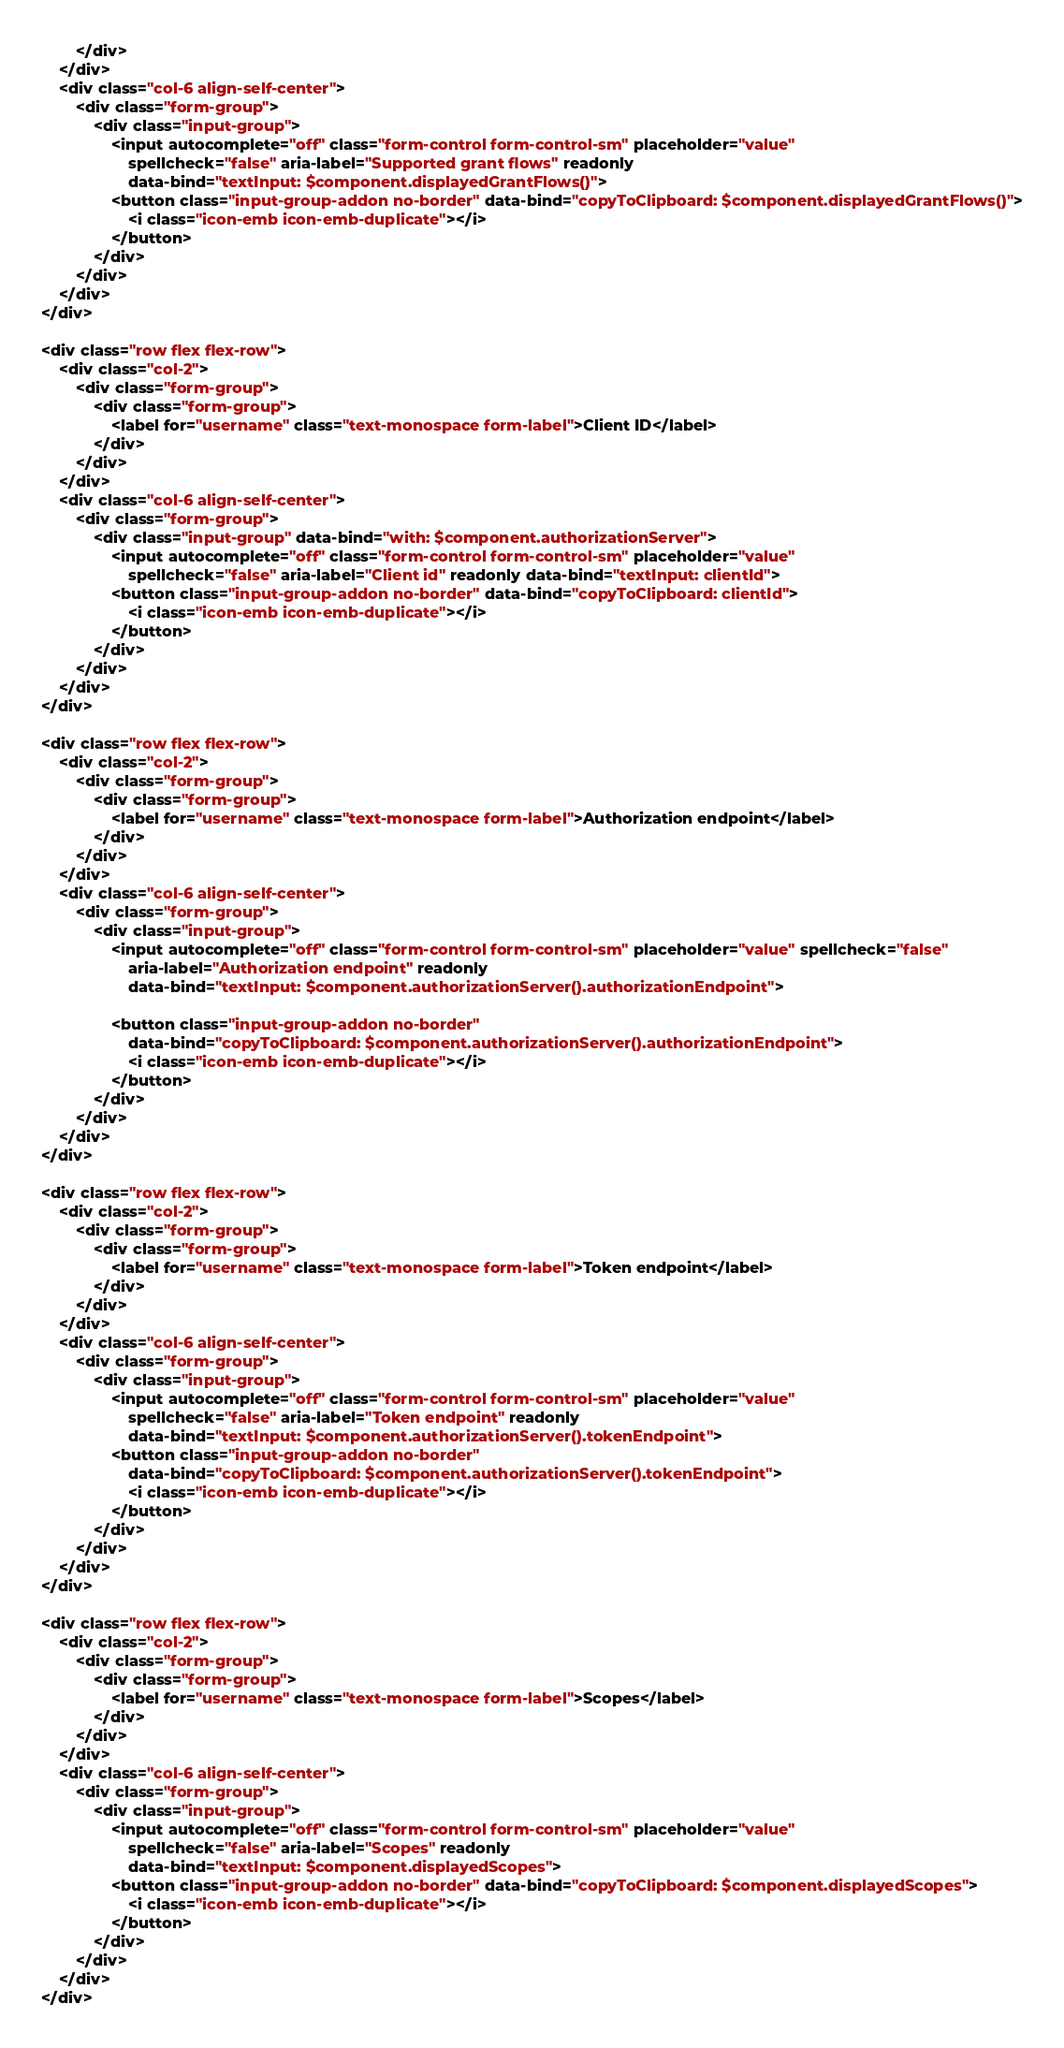<code> <loc_0><loc_0><loc_500><loc_500><_HTML_>        </div>
    </div>
    <div class="col-6 align-self-center">
        <div class="form-group">
            <div class="input-group">
                <input autocomplete="off" class="form-control form-control-sm" placeholder="value"
                    spellcheck="false" aria-label="Supported grant flows" readonly
                    data-bind="textInput: $component.displayedGrantFlows()">
                <button class="input-group-addon no-border" data-bind="copyToClipboard: $component.displayedGrantFlows()">
                    <i class="icon-emb icon-emb-duplicate"></i>
                </button>
            </div>
        </div>
    </div>
</div>

<div class="row flex flex-row">
    <div class="col-2">
        <div class="form-group">
            <div class="form-group">
                <label for="username" class="text-monospace form-label">Client ID</label>
            </div>
        </div>
    </div>
    <div class="col-6 align-self-center">
        <div class="form-group">
            <div class="input-group" data-bind="with: $component.authorizationServer">
                <input autocomplete="off" class="form-control form-control-sm" placeholder="value"
                    spellcheck="false" aria-label="Client id" readonly data-bind="textInput: clientId">
                <button class="input-group-addon no-border" data-bind="copyToClipboard: clientId">
                    <i class="icon-emb icon-emb-duplicate"></i>
                </button>
            </div>
        </div>
    </div>
</div>

<div class="row flex flex-row">
    <div class="col-2">
        <div class="form-group">
            <div class="form-group">
                <label for="username" class="text-monospace form-label">Authorization endpoint</label>
            </div>
        </div>
    </div>
    <div class="col-6 align-self-center">
        <div class="form-group">
            <div class="input-group">
                <input autocomplete="off" class="form-control form-control-sm" placeholder="value" spellcheck="false"
                    aria-label="Authorization endpoint" readonly
                    data-bind="textInput: $component.authorizationServer().authorizationEndpoint">

                <button class="input-group-addon no-border"
                    data-bind="copyToClipboard: $component.authorizationServer().authorizationEndpoint">
                    <i class="icon-emb icon-emb-duplicate"></i>
                </button>
            </div>
        </div>
    </div>
</div>

<div class="row flex flex-row">
    <div class="col-2">
        <div class="form-group">
            <div class="form-group">
                <label for="username" class="text-monospace form-label">Token endpoint</label>
            </div>
        </div>
    </div>
    <div class="col-6 align-self-center">
        <div class="form-group">
            <div class="input-group">
                <input autocomplete="off" class="form-control form-control-sm" placeholder="value"
                    spellcheck="false" aria-label="Token endpoint" readonly
                    data-bind="textInput: $component.authorizationServer().tokenEndpoint">
                <button class="input-group-addon no-border"
                    data-bind="copyToClipboard: $component.authorizationServer().tokenEndpoint">
                    <i class="icon-emb icon-emb-duplicate"></i>
                </button>
            </div>
        </div>
    </div>
</div>

<div class="row flex flex-row">
    <div class="col-2">
        <div class="form-group">
            <div class="form-group">
                <label for="username" class="text-monospace form-label">Scopes</label>
            </div>
        </div>
    </div>
    <div class="col-6 align-self-center">
        <div class="form-group">
            <div class="input-group">
                <input autocomplete="off" class="form-control form-control-sm" placeholder="value"
                    spellcheck="false" aria-label="Scopes" readonly
                    data-bind="textInput: $component.displayedScopes">
                <button class="input-group-addon no-border" data-bind="copyToClipboard: $component.displayedScopes">
                    <i class="icon-emb icon-emb-duplicate"></i>
                </button>
            </div>
        </div>
    </div>
</div></code> 